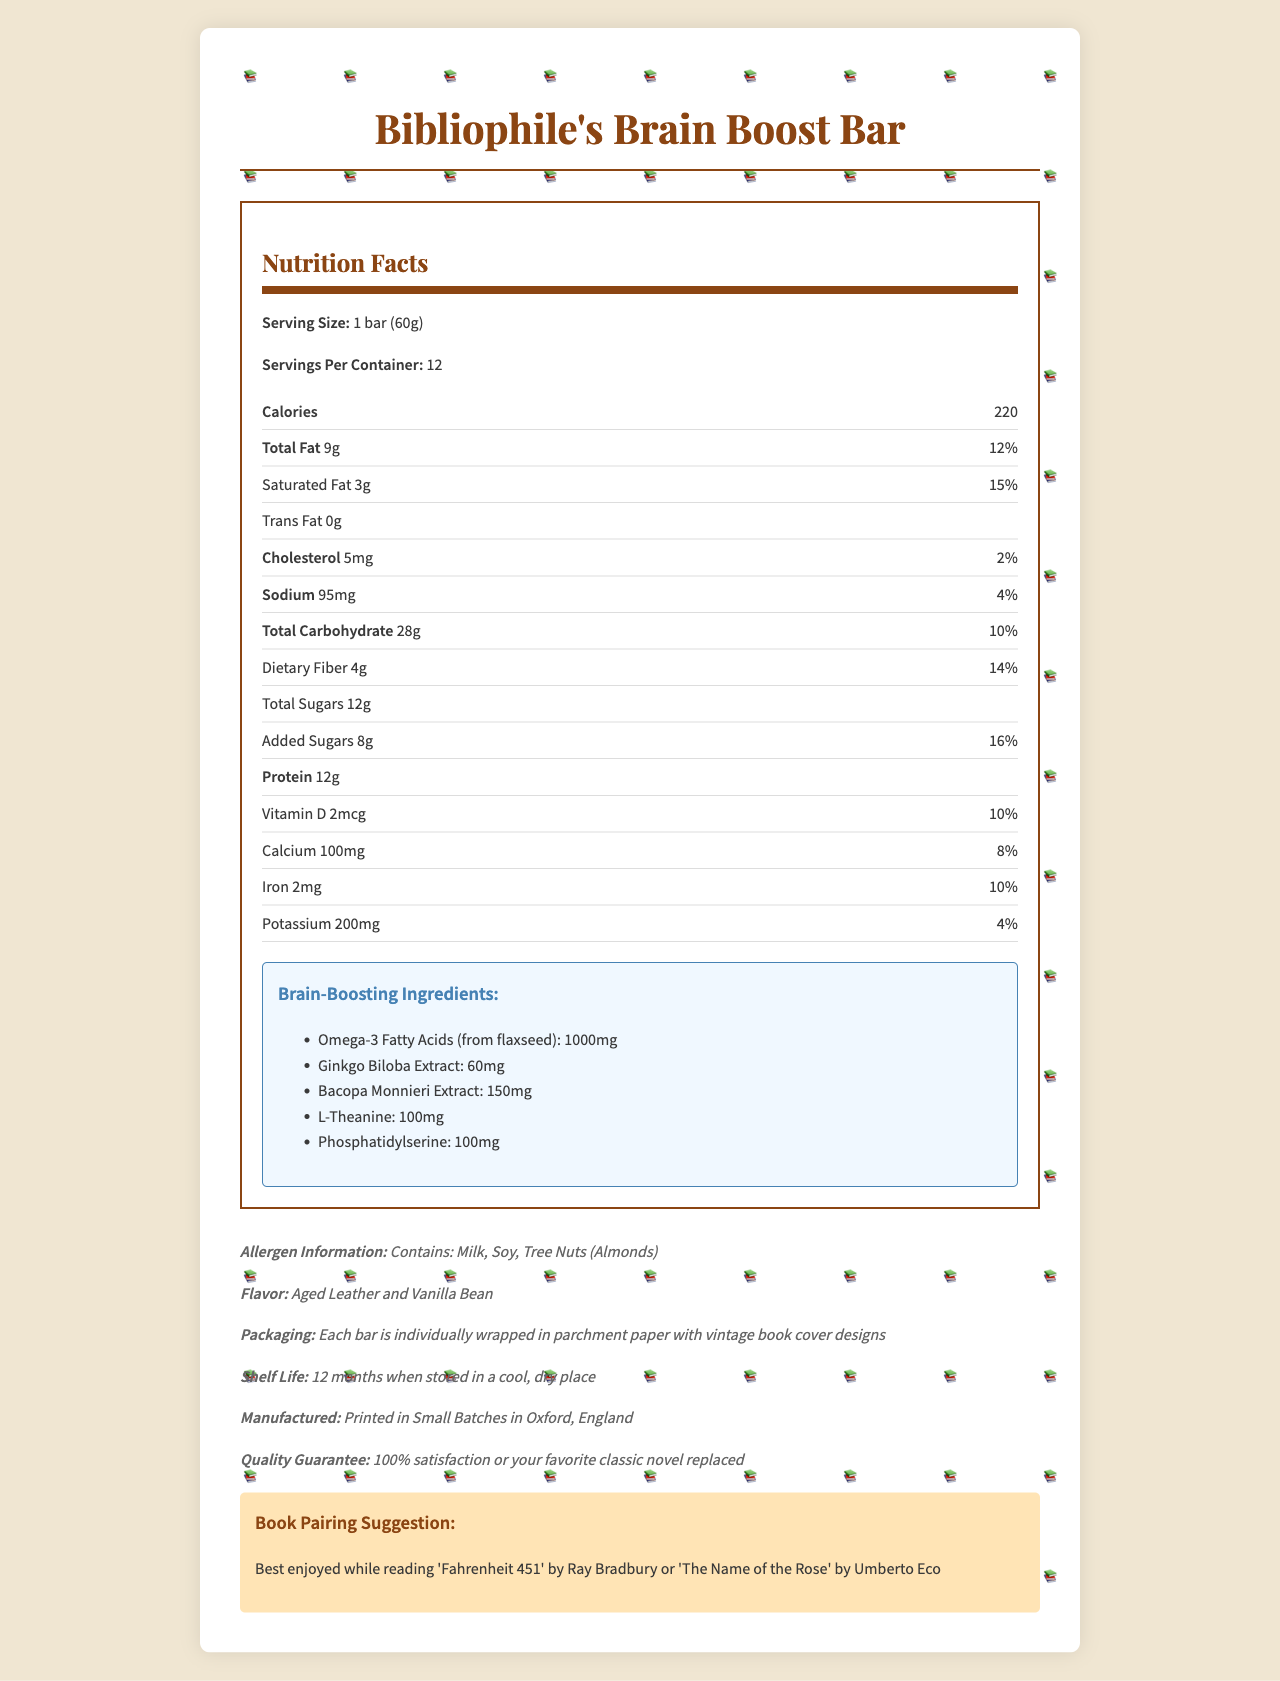What is the serving size of the Bibliophile's Brain Boost Bar? The serving size is listed as "1 bar (60g)" in the Nutrition Facts section.
Answer: 1 bar (60g) How many servings are there per container? The number of servings per container is clearly stated as 12.
Answer: 12 How many calories are in one serving of the bar? The Nutrition Facts section shows that there are 220 calories per serving.
Answer: 220 What are the brain-boosting ingredients included in the bar? The ingredients are listed under the "Brain-Boosting Ingredients" section.
Answer: Omega-3 Fatty Acids (from flaxseed), Ginkgo Biloba Extract, Bacopa Monnieri Extract, L-Theanine, Phosphatidylserine What is the total fat content in one serving, and what percentage of the daily value does it represent? The document specifies that one serving contains 9g of total fat, which is 12% of the daily value.
Answer: 9g, 12% How many grams of added sugars are in one bar? The added sugars content in one bar is listed as 8g.
Answer: 8g What is the main flavor description of the Brain Boost Bar? The flavor description is provided as "Aged Leather and Vanilla Bean".
Answer: Aged Leather and Vanilla Bean What allergen information is listed for the Brain Boost Bar? The allergen information states that the bar contains milk, soy, and tree nuts (almonds).
Answer: Contains: Milk, Soy, Tree Nuts (Almonds) What is the recommended book pairing for this Brain Boost Bar? A. The Great Gatsby B. Fahrenheit 451 C. Moby Dick The book pairing suggestion reads "Best enjoyed while reading 'Fahrenheit 451' by Ray Bradbury or 'The Name of the Rose' by Umberto Eco".
Answer: B. Fahrenheit 451 Which of the following brain-boosting ingredients is present in the highest amount? A. Omega-3 Fatty Acids B. Ginkgo Biloba Extract C. Bacopa Monnieri Extract D. L-Theanine The list of brain-boosting ingredients shows that Omega-3 Fatty Acids are present in the largest amount (1000mg).
Answer: A. Omega-3 Fatty Acids Does the Brain Boost Bar contain any cholesterol? The document shows that the bar contains 5mg of cholesterol, which is 2% of the daily value.
Answer: Yes Summarize the main features highlighted in the Bibliophile’s Brain Boost Bar document. The document details the nutritional content, brain-boosting ingredients, flavor, packaging, and book pairing suggestions of the protein bar, as well as allergen information and a quality guarantee.
Answer: The Bibliophile’s Brain Boost Bar is a protein bar with brain-boosting ingredients designed for book lovers. Each serving has 220 calories and contains ingredients like Omega-3 Fatty Acids, Ginkgo Biloba Extract, and L-Theanine. The bar has 12g of protein, is flavored with Aged Leather and Vanilla Bean, and is packaged with vintage book cover designs. It’s recommended to be enjoyed while reading specific classic books. It contains allergens like milk, soy, and tree nuts. How much Calcium does one serving provide? The document lists the calcium content as 100mg, which is 8% of the daily value.
Answer: 100mg, 8% Can you find out the price of one container from the document? The document does not provide any information on pricing.
Answer: Not enough information Which country is the Brain Boost Bar manufactured in? The manufacturing location is mentioned as "Printed in Small Batches in Oxford, England".
Answer: England 